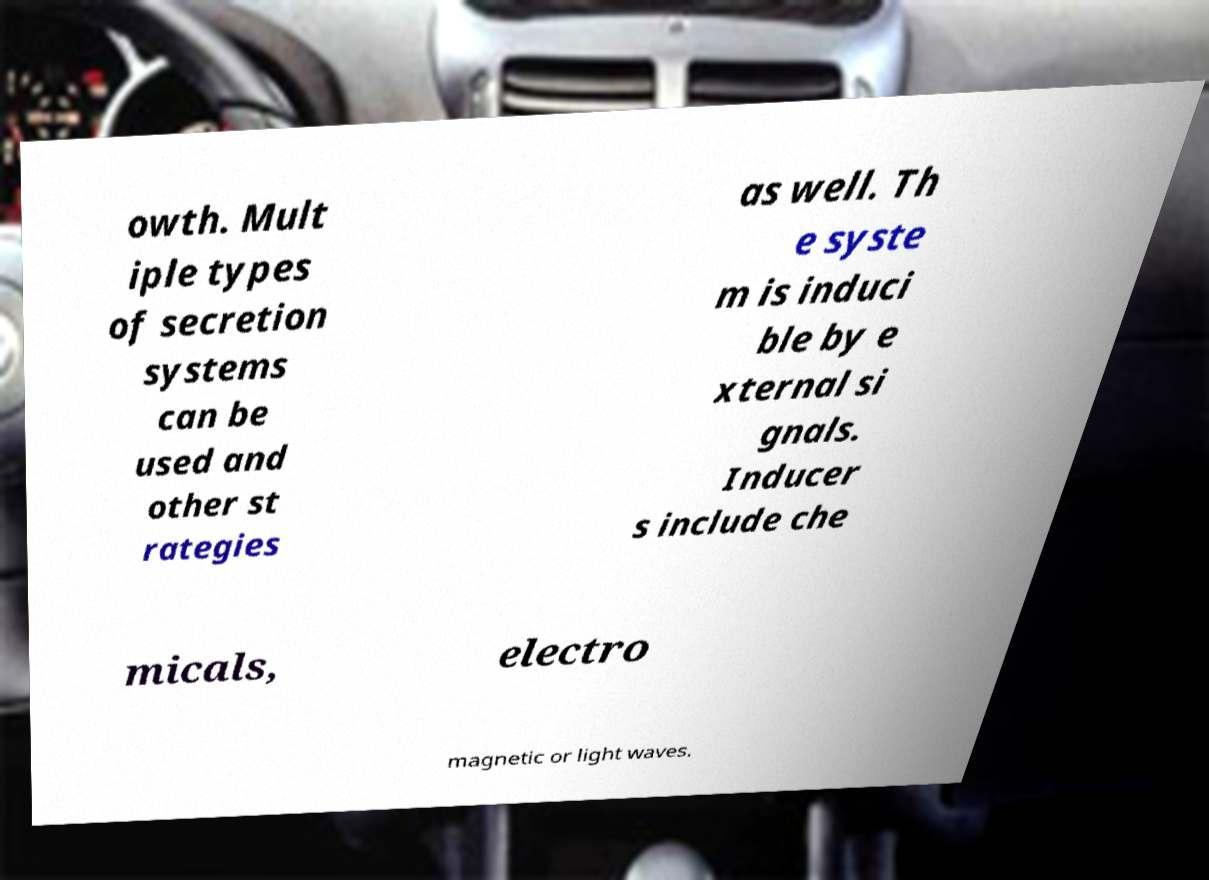Please identify and transcribe the text found in this image. owth. Mult iple types of secretion systems can be used and other st rategies as well. Th e syste m is induci ble by e xternal si gnals. Inducer s include che micals, electro magnetic or light waves. 